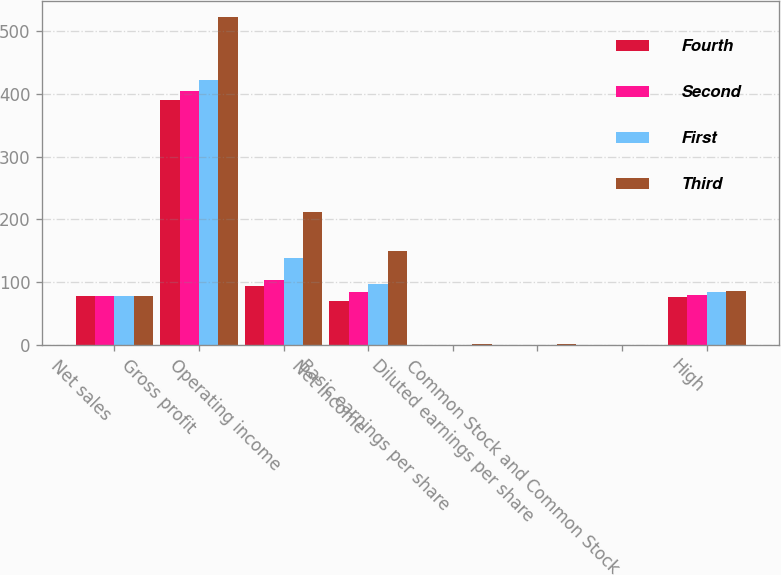Convert chart to OTSL. <chart><loc_0><loc_0><loc_500><loc_500><stacked_bar_chart><ecel><fcel>Net sales<fcel>Gross profit<fcel>Operating income<fcel>Net income<fcel>Basic earnings per share<fcel>Diluted earnings per share<fcel>Common Stock and Common Stock<fcel>High<nl><fcel>Fourth<fcel>77.95<fcel>389.7<fcel>93.7<fcel>70.5<fcel>0.55<fcel>0.55<fcel>0.4<fcel>76.37<nl><fcel>Second<fcel>77.95<fcel>404<fcel>103.8<fcel>84.3<fcel>0.66<fcel>0.65<fcel>0.4<fcel>79.53<nl><fcel>First<fcel>77.95<fcel>421.9<fcel>138.7<fcel>97.6<fcel>0.76<fcel>0.76<fcel>0.4<fcel>84.89<nl><fcel>Third<fcel>77.95<fcel>521.7<fcel>212.2<fcel>149.2<fcel>1.17<fcel>1.16<fcel>0.4<fcel>86.04<nl></chart> 